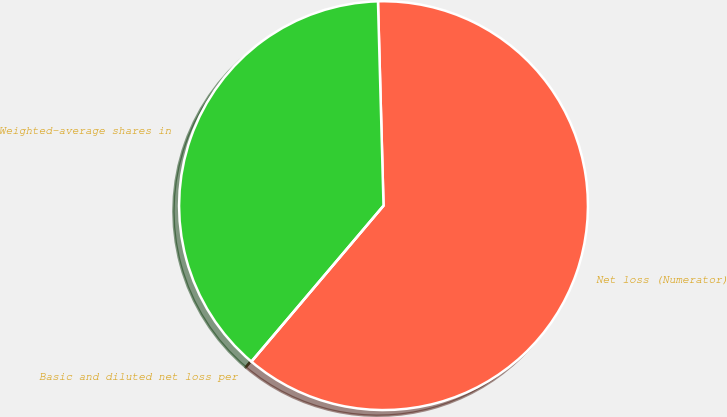Convert chart. <chart><loc_0><loc_0><loc_500><loc_500><pie_chart><fcel>Net loss (Numerator)<fcel>Weighted-average shares in<fcel>Basic and diluted net loss per<nl><fcel>61.62%<fcel>38.38%<fcel>0.0%<nl></chart> 